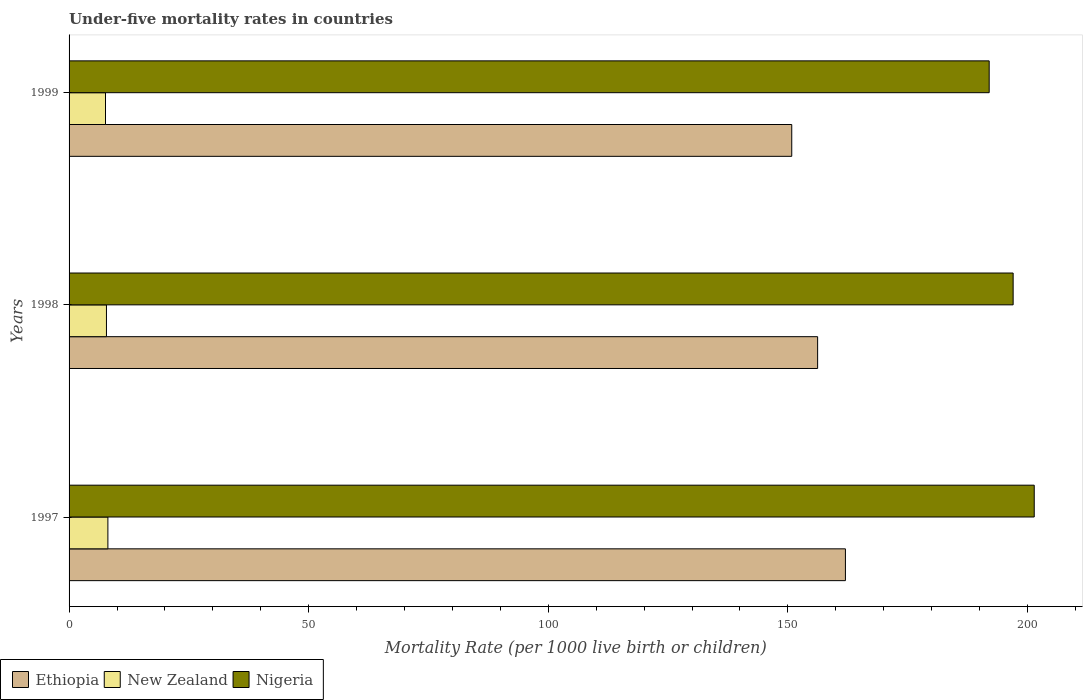Are the number of bars per tick equal to the number of legend labels?
Give a very brief answer. Yes. How many bars are there on the 3rd tick from the top?
Your answer should be very brief. 3. How many bars are there on the 2nd tick from the bottom?
Your answer should be compact. 3. What is the label of the 3rd group of bars from the top?
Make the answer very short. 1997. What is the under-five mortality rate in Nigeria in 1999?
Ensure brevity in your answer.  192. In which year was the under-five mortality rate in Nigeria minimum?
Ensure brevity in your answer.  1999. What is the total under-five mortality rate in Ethiopia in the graph?
Give a very brief answer. 469. What is the difference between the under-five mortality rate in New Zealand in 1997 and that in 1998?
Provide a short and direct response. 0.3. What is the difference between the under-five mortality rate in Ethiopia in 1998 and the under-five mortality rate in New Zealand in 1999?
Your answer should be compact. 148.6. What is the average under-five mortality rate in Nigeria per year?
Your answer should be compact. 196.8. In the year 1998, what is the difference between the under-five mortality rate in New Zealand and under-five mortality rate in Nigeria?
Offer a terse response. -189.2. What is the ratio of the under-five mortality rate in New Zealand in 1997 to that in 1999?
Provide a short and direct response. 1.07. Is the under-five mortality rate in Nigeria in 1998 less than that in 1999?
Offer a very short reply. No. What is the difference between the highest and the second highest under-five mortality rate in Ethiopia?
Make the answer very short. 5.8. What is the difference between the highest and the lowest under-five mortality rate in New Zealand?
Provide a succinct answer. 0.5. In how many years, is the under-five mortality rate in New Zealand greater than the average under-five mortality rate in New Zealand taken over all years?
Make the answer very short. 1. Is the sum of the under-five mortality rate in Ethiopia in 1997 and 1998 greater than the maximum under-five mortality rate in Nigeria across all years?
Give a very brief answer. Yes. What does the 2nd bar from the top in 1997 represents?
Offer a terse response. New Zealand. What does the 3rd bar from the bottom in 1999 represents?
Keep it short and to the point. Nigeria. Is it the case that in every year, the sum of the under-five mortality rate in New Zealand and under-five mortality rate in Ethiopia is greater than the under-five mortality rate in Nigeria?
Give a very brief answer. No. How many bars are there?
Provide a short and direct response. 9. Are all the bars in the graph horizontal?
Your answer should be compact. Yes. Are the values on the major ticks of X-axis written in scientific E-notation?
Give a very brief answer. No. Does the graph contain grids?
Make the answer very short. No. How many legend labels are there?
Offer a very short reply. 3. How are the legend labels stacked?
Your answer should be very brief. Horizontal. What is the title of the graph?
Provide a succinct answer. Under-five mortality rates in countries. What is the label or title of the X-axis?
Ensure brevity in your answer.  Mortality Rate (per 1000 live birth or children). What is the label or title of the Y-axis?
Your response must be concise. Years. What is the Mortality Rate (per 1000 live birth or children) in Ethiopia in 1997?
Provide a short and direct response. 162. What is the Mortality Rate (per 1000 live birth or children) of Nigeria in 1997?
Offer a terse response. 201.4. What is the Mortality Rate (per 1000 live birth or children) in Ethiopia in 1998?
Offer a terse response. 156.2. What is the Mortality Rate (per 1000 live birth or children) of New Zealand in 1998?
Provide a short and direct response. 7.8. What is the Mortality Rate (per 1000 live birth or children) of Nigeria in 1998?
Make the answer very short. 197. What is the Mortality Rate (per 1000 live birth or children) of Ethiopia in 1999?
Provide a short and direct response. 150.8. What is the Mortality Rate (per 1000 live birth or children) in New Zealand in 1999?
Your answer should be very brief. 7.6. What is the Mortality Rate (per 1000 live birth or children) of Nigeria in 1999?
Give a very brief answer. 192. Across all years, what is the maximum Mortality Rate (per 1000 live birth or children) in Ethiopia?
Offer a terse response. 162. Across all years, what is the maximum Mortality Rate (per 1000 live birth or children) in Nigeria?
Offer a terse response. 201.4. Across all years, what is the minimum Mortality Rate (per 1000 live birth or children) in Ethiopia?
Make the answer very short. 150.8. Across all years, what is the minimum Mortality Rate (per 1000 live birth or children) in New Zealand?
Keep it short and to the point. 7.6. Across all years, what is the minimum Mortality Rate (per 1000 live birth or children) of Nigeria?
Ensure brevity in your answer.  192. What is the total Mortality Rate (per 1000 live birth or children) of Ethiopia in the graph?
Provide a short and direct response. 469. What is the total Mortality Rate (per 1000 live birth or children) in New Zealand in the graph?
Provide a short and direct response. 23.5. What is the total Mortality Rate (per 1000 live birth or children) in Nigeria in the graph?
Provide a succinct answer. 590.4. What is the difference between the Mortality Rate (per 1000 live birth or children) of Ethiopia in 1997 and that in 1998?
Offer a very short reply. 5.8. What is the difference between the Mortality Rate (per 1000 live birth or children) in Nigeria in 1997 and that in 1998?
Your response must be concise. 4.4. What is the difference between the Mortality Rate (per 1000 live birth or children) of New Zealand in 1997 and that in 1999?
Your response must be concise. 0.5. What is the difference between the Mortality Rate (per 1000 live birth or children) in New Zealand in 1998 and that in 1999?
Provide a short and direct response. 0.2. What is the difference between the Mortality Rate (per 1000 live birth or children) in Ethiopia in 1997 and the Mortality Rate (per 1000 live birth or children) in New Zealand in 1998?
Ensure brevity in your answer.  154.2. What is the difference between the Mortality Rate (per 1000 live birth or children) in Ethiopia in 1997 and the Mortality Rate (per 1000 live birth or children) in Nigeria in 1998?
Your answer should be compact. -35. What is the difference between the Mortality Rate (per 1000 live birth or children) in New Zealand in 1997 and the Mortality Rate (per 1000 live birth or children) in Nigeria in 1998?
Your answer should be very brief. -188.9. What is the difference between the Mortality Rate (per 1000 live birth or children) in Ethiopia in 1997 and the Mortality Rate (per 1000 live birth or children) in New Zealand in 1999?
Provide a succinct answer. 154.4. What is the difference between the Mortality Rate (per 1000 live birth or children) of Ethiopia in 1997 and the Mortality Rate (per 1000 live birth or children) of Nigeria in 1999?
Provide a short and direct response. -30. What is the difference between the Mortality Rate (per 1000 live birth or children) of New Zealand in 1997 and the Mortality Rate (per 1000 live birth or children) of Nigeria in 1999?
Your response must be concise. -183.9. What is the difference between the Mortality Rate (per 1000 live birth or children) in Ethiopia in 1998 and the Mortality Rate (per 1000 live birth or children) in New Zealand in 1999?
Give a very brief answer. 148.6. What is the difference between the Mortality Rate (per 1000 live birth or children) of Ethiopia in 1998 and the Mortality Rate (per 1000 live birth or children) of Nigeria in 1999?
Your answer should be compact. -35.8. What is the difference between the Mortality Rate (per 1000 live birth or children) of New Zealand in 1998 and the Mortality Rate (per 1000 live birth or children) of Nigeria in 1999?
Keep it short and to the point. -184.2. What is the average Mortality Rate (per 1000 live birth or children) in Ethiopia per year?
Your answer should be very brief. 156.33. What is the average Mortality Rate (per 1000 live birth or children) in New Zealand per year?
Ensure brevity in your answer.  7.83. What is the average Mortality Rate (per 1000 live birth or children) of Nigeria per year?
Offer a terse response. 196.8. In the year 1997, what is the difference between the Mortality Rate (per 1000 live birth or children) in Ethiopia and Mortality Rate (per 1000 live birth or children) in New Zealand?
Keep it short and to the point. 153.9. In the year 1997, what is the difference between the Mortality Rate (per 1000 live birth or children) in Ethiopia and Mortality Rate (per 1000 live birth or children) in Nigeria?
Provide a short and direct response. -39.4. In the year 1997, what is the difference between the Mortality Rate (per 1000 live birth or children) in New Zealand and Mortality Rate (per 1000 live birth or children) in Nigeria?
Your answer should be very brief. -193.3. In the year 1998, what is the difference between the Mortality Rate (per 1000 live birth or children) of Ethiopia and Mortality Rate (per 1000 live birth or children) of New Zealand?
Ensure brevity in your answer.  148.4. In the year 1998, what is the difference between the Mortality Rate (per 1000 live birth or children) in Ethiopia and Mortality Rate (per 1000 live birth or children) in Nigeria?
Your answer should be very brief. -40.8. In the year 1998, what is the difference between the Mortality Rate (per 1000 live birth or children) in New Zealand and Mortality Rate (per 1000 live birth or children) in Nigeria?
Give a very brief answer. -189.2. In the year 1999, what is the difference between the Mortality Rate (per 1000 live birth or children) of Ethiopia and Mortality Rate (per 1000 live birth or children) of New Zealand?
Your response must be concise. 143.2. In the year 1999, what is the difference between the Mortality Rate (per 1000 live birth or children) in Ethiopia and Mortality Rate (per 1000 live birth or children) in Nigeria?
Keep it short and to the point. -41.2. In the year 1999, what is the difference between the Mortality Rate (per 1000 live birth or children) of New Zealand and Mortality Rate (per 1000 live birth or children) of Nigeria?
Your answer should be very brief. -184.4. What is the ratio of the Mortality Rate (per 1000 live birth or children) in Ethiopia in 1997 to that in 1998?
Your answer should be very brief. 1.04. What is the ratio of the Mortality Rate (per 1000 live birth or children) in Nigeria in 1997 to that in 1998?
Offer a very short reply. 1.02. What is the ratio of the Mortality Rate (per 1000 live birth or children) in Ethiopia in 1997 to that in 1999?
Provide a short and direct response. 1.07. What is the ratio of the Mortality Rate (per 1000 live birth or children) in New Zealand in 1997 to that in 1999?
Give a very brief answer. 1.07. What is the ratio of the Mortality Rate (per 1000 live birth or children) in Nigeria in 1997 to that in 1999?
Make the answer very short. 1.05. What is the ratio of the Mortality Rate (per 1000 live birth or children) in Ethiopia in 1998 to that in 1999?
Ensure brevity in your answer.  1.04. What is the ratio of the Mortality Rate (per 1000 live birth or children) of New Zealand in 1998 to that in 1999?
Offer a terse response. 1.03. What is the ratio of the Mortality Rate (per 1000 live birth or children) of Nigeria in 1998 to that in 1999?
Ensure brevity in your answer.  1.03. What is the difference between the highest and the second highest Mortality Rate (per 1000 live birth or children) in Nigeria?
Provide a succinct answer. 4.4. What is the difference between the highest and the lowest Mortality Rate (per 1000 live birth or children) of Nigeria?
Offer a very short reply. 9.4. 